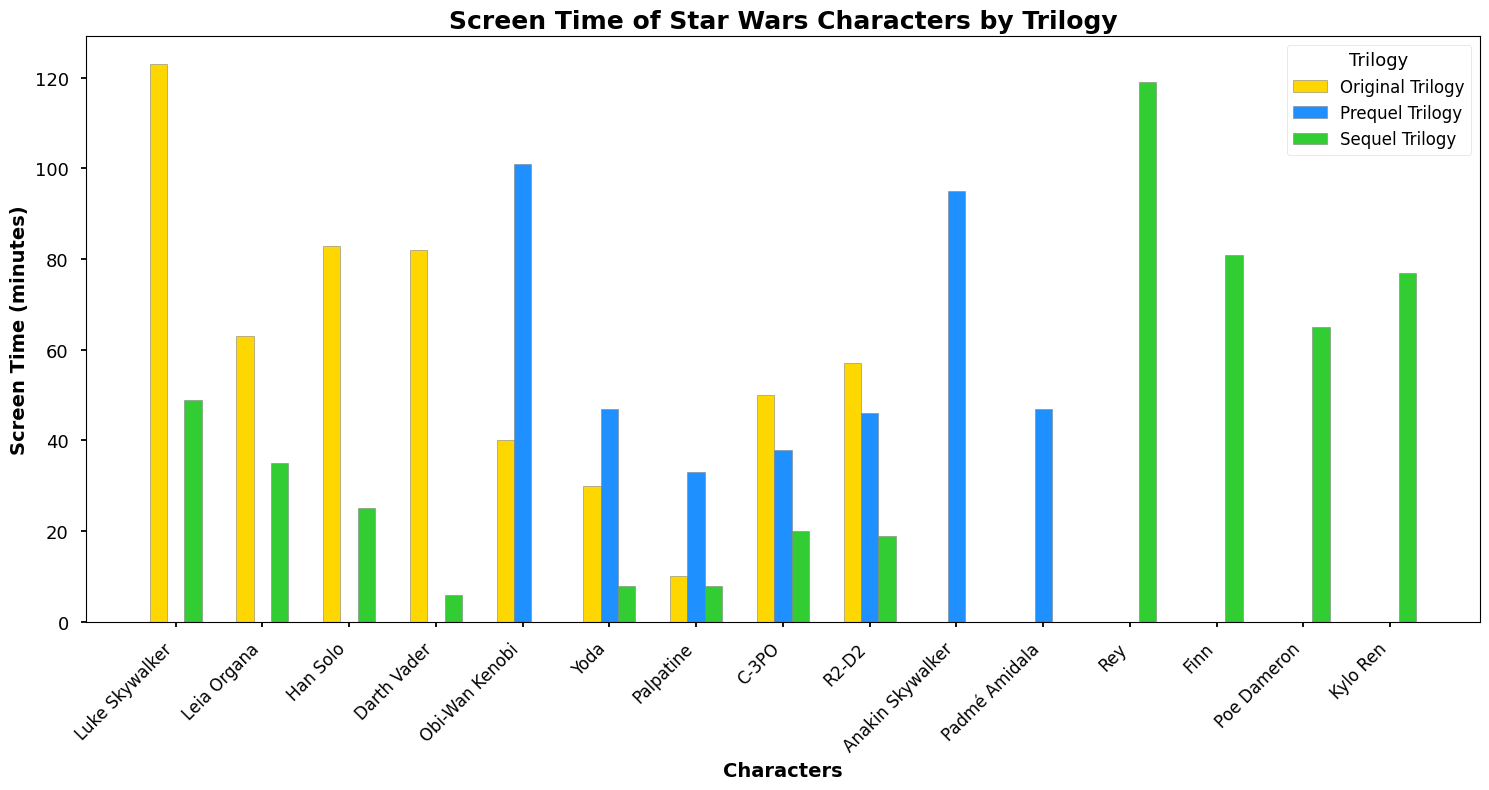Who has the most screen time in the Original Trilogy? Look at the bar heights for the Original Trilogy (yellow bars). Luke Skywalker has the tallest bar, indicating he has the most screen time.
Answer: Luke Skywalker Which character appears in all three trilogies and what is their total screen time? Find characters with bars in all three sets: Luke Skywalker, Leia Organa, Han Solo, Darth Vader, Yoda, Palpatine, C-3PO, and R2-D2. Sum their screen times. Luke Skywalker: 123+0+49=172; Leia Organa: 63+0+35=98; Han Solo: 83+0+25=108; Darth Vader: 82+0+6=88; Yoda: 30+47+8=85; Palpatine: 10+33+8=51; C-3PO: 50+38+20=108; R2-D2: 57+46+19=122. Luke Skywalker has the most total screen time.
Answer: Luke Skywalker, 172 minutes How much more screen time does Rey have compared to Finn in the Sequel Trilogy? Look at the green bars. Rey's screen time is 119 minutes and Finn's is 81 minutes. Subtract Finn's time from Rey's: 119 - 81 = 38 minutes.
Answer: 38 minutes Who has the least screen time in the Prequel Trilogy? Look at the height of the blue bars. Darth Vader has the shortest bar, indicating he has the least screen time.
Answer: Darth Vader Which trilogy has the highest combined screen time for Yoda? Add up Yoda's screen times from all trilogies: Original (30), Prequel (47), and Sequel (8). Calculate total for each: Original=30, Prequel=47, Sequel=8. The Prequel Trilogy has the highest combined screen time for Yoda.
Answer: Prequel Trilogy What’s the average screen time of all characters in the Original Trilogy? Sum the screen times for all characters in the Original Trilogy and divide by the number of characters: (123 + 63 + 83 + 82 + 40 + 30 + 10 + 50 + 57) / 9 = 538/9 ≈ 59.78 minutes.
Answer: 59.78 minutes Do Obi-Wan Kenobi and Anakin Skywalker appear in the Sequel Trilogy? Check if Obi-Wan Kenobi and Anakin Skywalker have green bars. Neither has a green bar, indicating no presence in the Sequel Trilogy.
Answer: No Which character saw a significant increase in screen time from the Original to the Prequel Trilogy? Compare the bar heights for each character between the Original (yellow bars) and Prequel (blue bars). Obi-Wan Kenobi increased from 40 to 101 minutes, a significant rise.
Answer: Obi-Wan Kenobi 